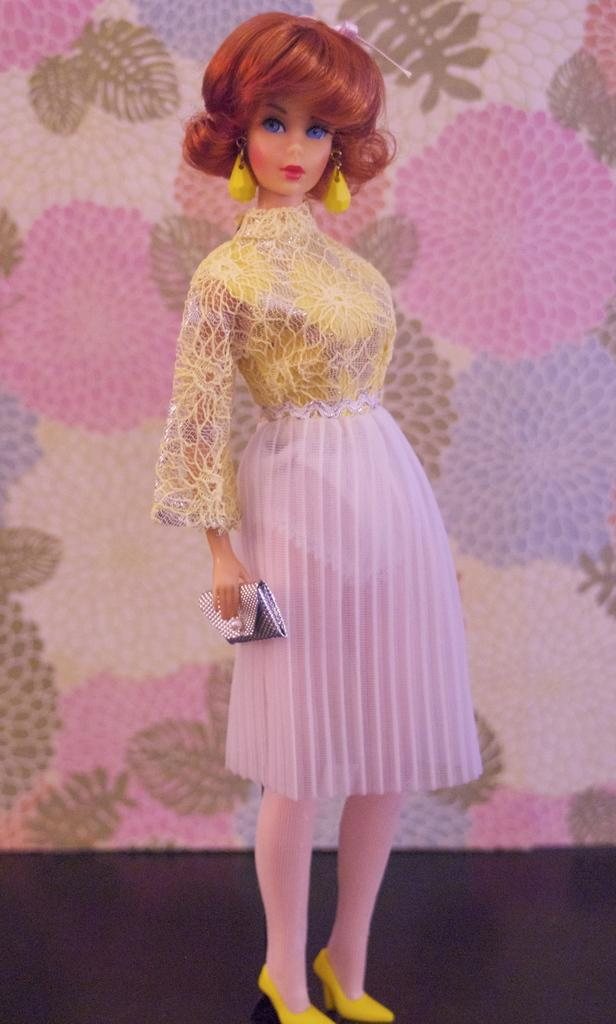What is the main subject of the image? There is a doll in the image that resembles a human. Can you describe the background of the image? There is a wall with a floral design in the background of the image. What type of pest can be seen climbing on the doll in the image? There is no pest present in the image; it features a doll and a wall with a floral design. Can you tell me how many gates are visible in the image? There are no gates present in the image. 